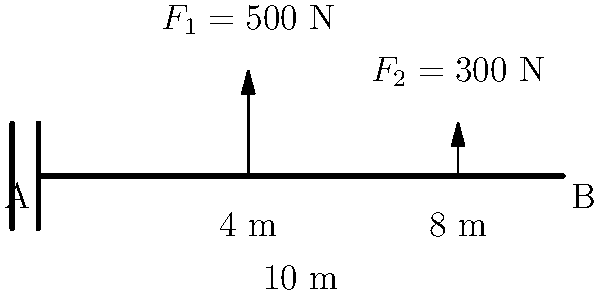A cantilever beam AB of length 10 m is fixed at end A and free at end B. Two point loads are applied to the beam: $F_1 = 500$ N at 4 m from the fixed end, and $F_2 = 300$ N at 8 m from the fixed end. Using the principle of superposition and the formula for maximum deflection of a cantilever beam with a point load, $\delta_{max} = \frac{F L^3}{3EI}$, calculate the maximum deflection at the free end B. Assume the beam has a modulus of elasticity $E = 200$ GPa and moment of inertia $I = 4 \times 10^{-6}$ m⁴. To solve this problem, we'll use the principle of superposition and follow these steps:

1) First, calculate the deflection caused by $F_1$:
   $\delta_1 = \frac{F_1 a^2 (3L - a)}{6EI}$
   Where $a = 4$ m (distance of $F_1$ from fixed end) and $L = 10$ m
   $\delta_1 = \frac{500 \cdot 4^2 (3 \cdot 10 - 4)}{6 \cdot 200 \times 10^9 \cdot 4 \times 10^{-6}} = 0.00333$ m

2) Next, calculate the deflection caused by $F_2$:
   $\delta_2 = \frac{F_2 a^2 (3L - a)}{6EI}$
   Where $a = 8$ m (distance of $F_2$ from fixed end) and $L = 10$ m
   $\delta_2 = \frac{300 \cdot 8^2 (3 \cdot 10 - 8)}{6 \cdot 200 \times 10^9 \cdot 4 \times 10^{-6}} = 0.00448$ m

3) The total deflection at point B is the sum of these two deflections:
   $\delta_{total} = \delta_1 + \delta_2 = 0.00333 + 0.00448 = 0.00781$ m

4) Convert the result to millimeters:
   $\delta_{total} = 0.00781 \cdot 1000 = 7.81$ mm

Therefore, the maximum deflection at the free end B is 7.81 mm.
Answer: 7.81 mm 